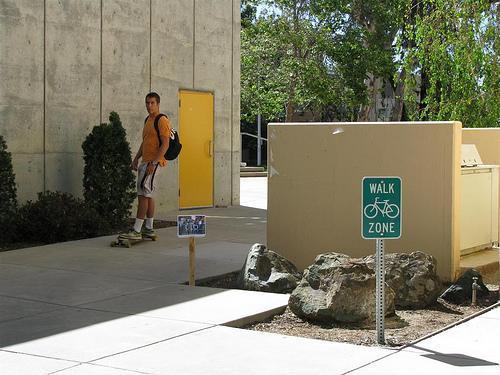How many bicycles are there?
Give a very brief answer. 0. How many zebras can you see?
Give a very brief answer. 0. 